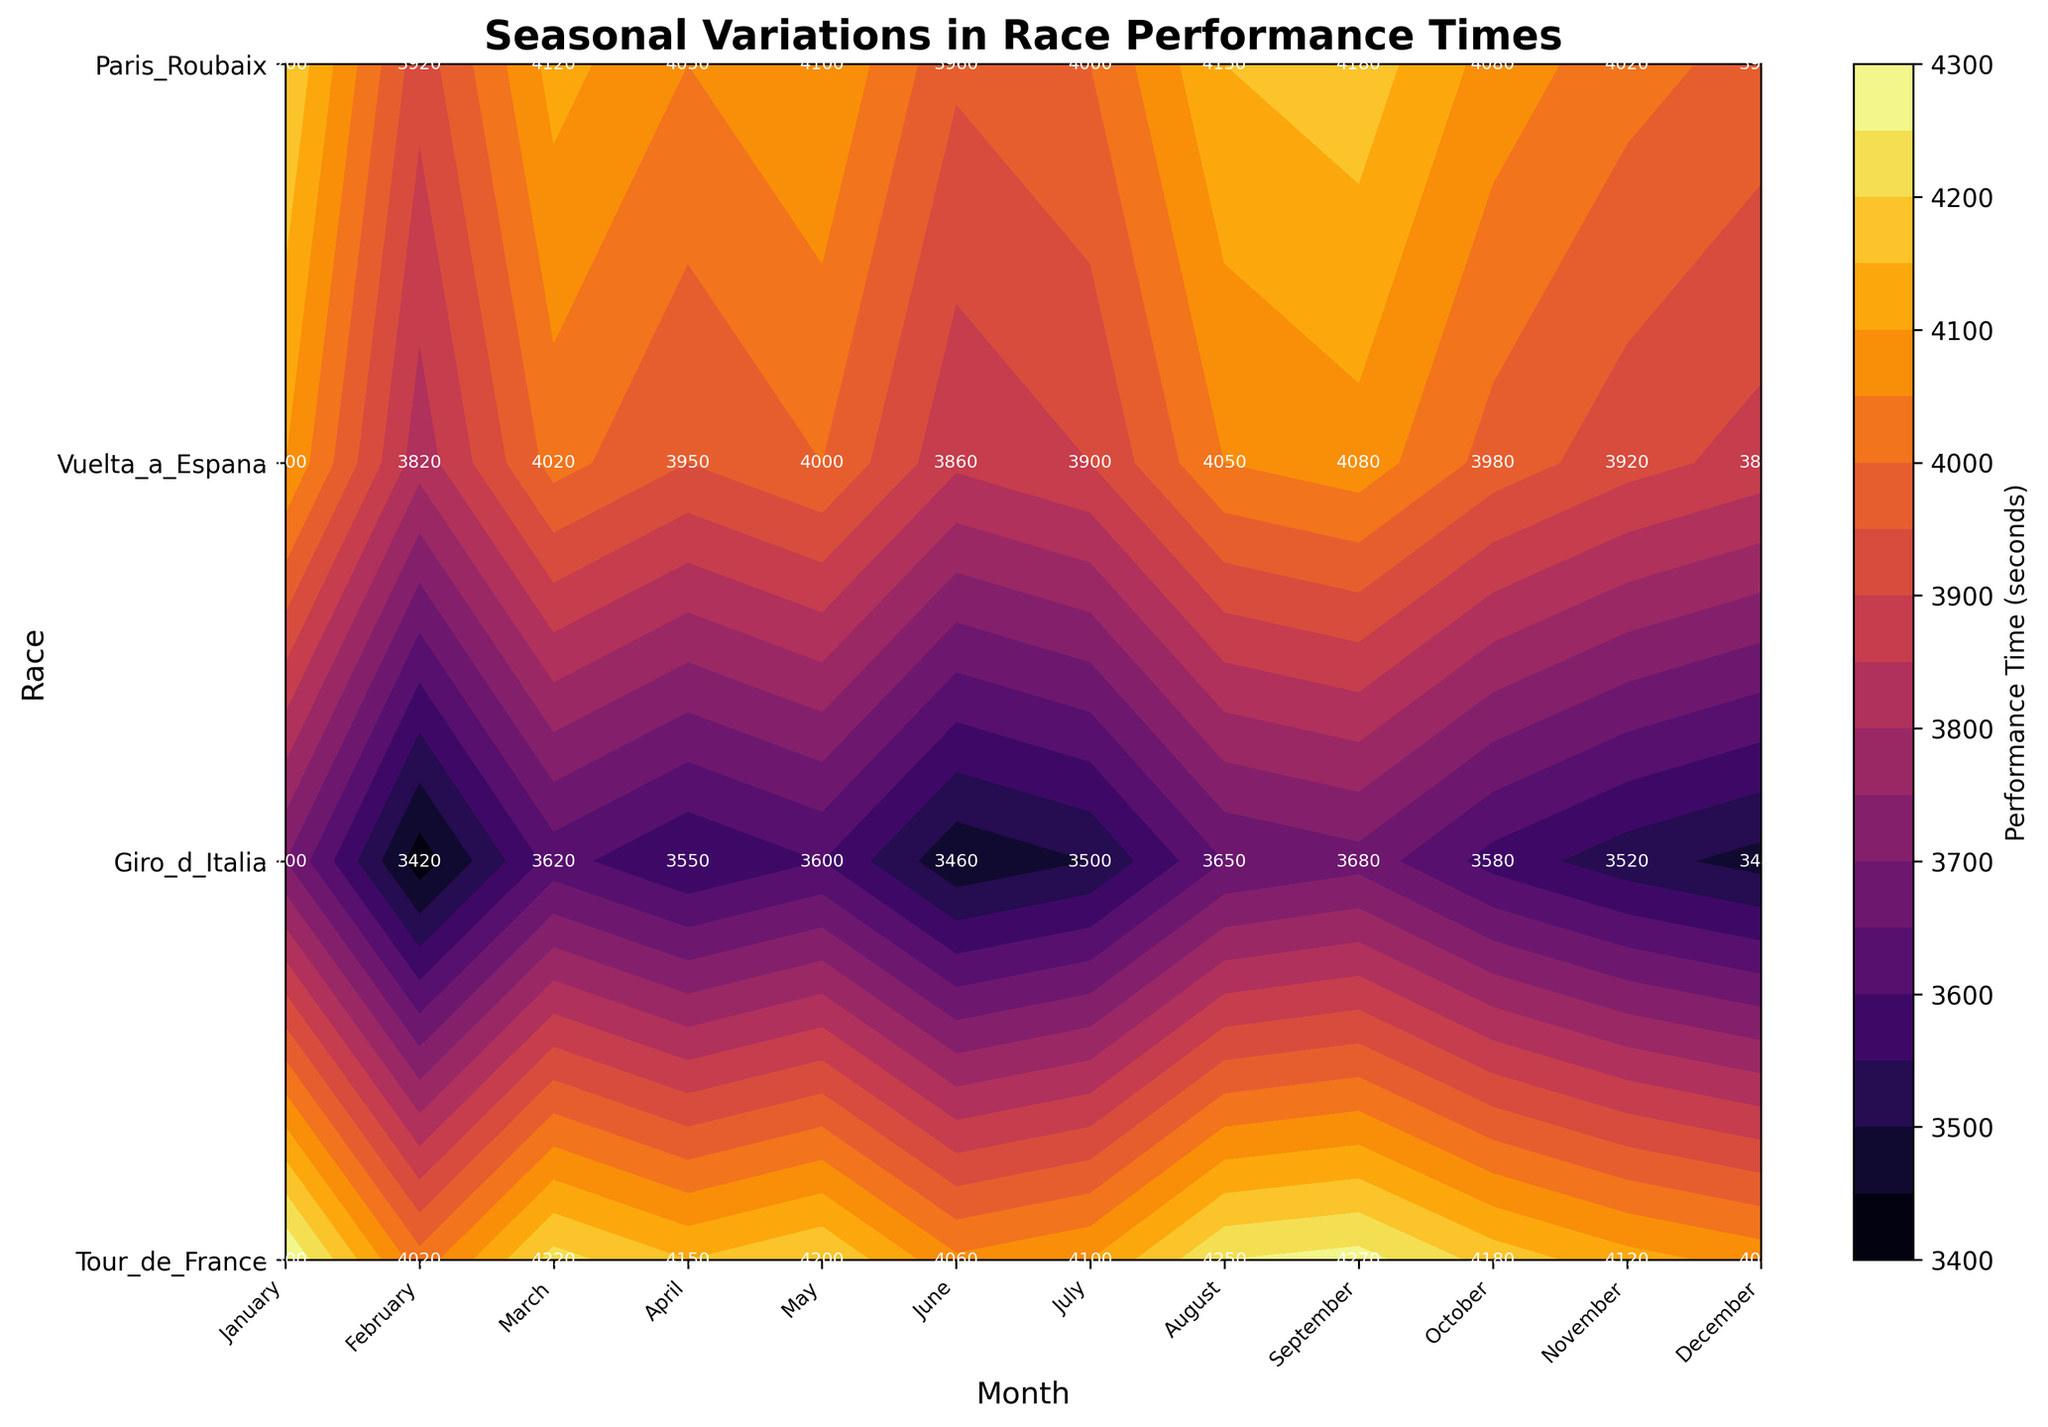What is the title of the plot? The title is written at the top of the plot.
Answer: "Seasonal Variations in Race Performance Times" How many races are displayed in the plot? Count the number of unique race names listed on the y-axis.
Answer: 4 Which month has the lowest performance time for the Tour de France race? Locate the Tour de France row, then find the minimum value in that row.
Answer: August What is the performance time for Giro d'Italia in October? Find the intersection of Giro d'Italia (on the y-axis) and October (on the x-axis).
Answer: 4120 Which race has consistently the lowest performance times across all months? Identify the race with generally lower contour values (darker color) and lower absolute performance times across all months.
Answer: Paris-Roubaix During which month are performance times highest for the Vuelta a España? Locate the Vuelta a España row, then find the maximum value in that row.
Answer: April What is the average performance time for the Tour de France in June and July? Add the values for June (3900) and July (3860), then divide by 2.
Answer: 3880 Which two races have the most similar performance times in December? Compare the performance times for December across all races, identify the two with the closest values.
Answer: Tour de France and Vuelta a España What is the performance time trend for the Paris-Roubaix race across the months? Observe the pattern of the contour lines for Paris-Roubaix; describe if they are generally increasing or decreasing.
Answer: Generally decreasing Which month exhibits the greatest performance time variability across all races? Compare the range of performance times (difference between maximum and minimum) for each month across all races.
Answer: January 